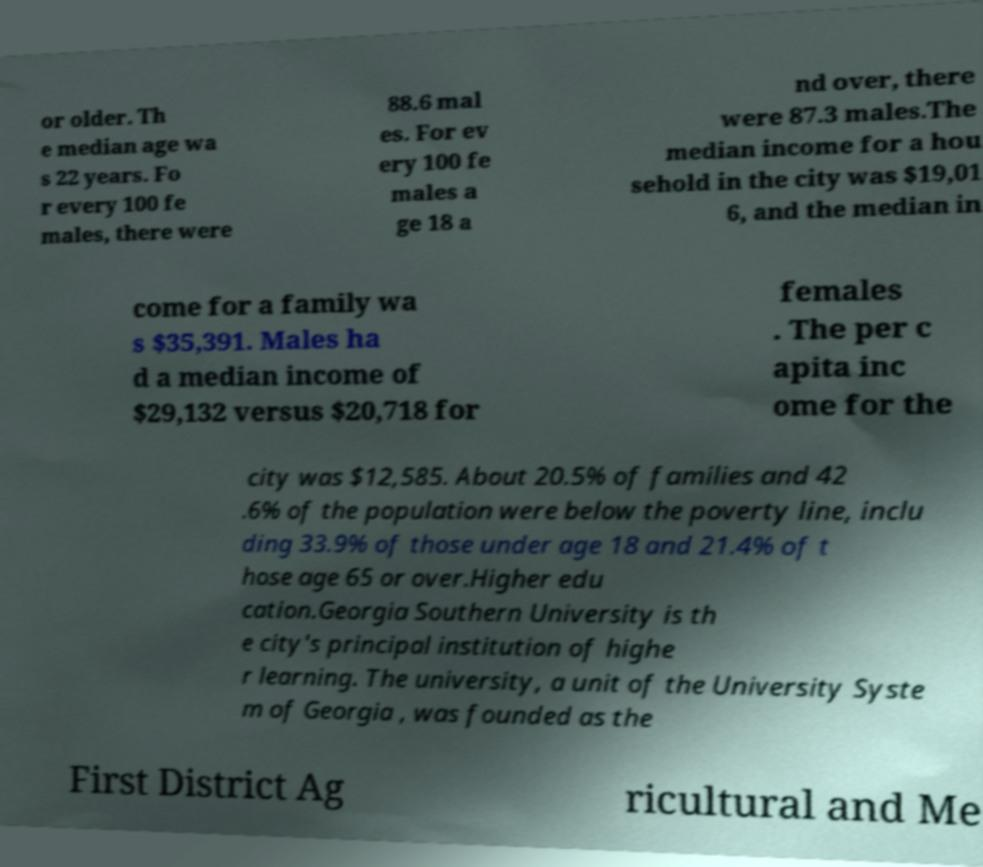Please identify and transcribe the text found in this image. or older. Th e median age wa s 22 years. Fo r every 100 fe males, there were 88.6 mal es. For ev ery 100 fe males a ge 18 a nd over, there were 87.3 males.The median income for a hou sehold in the city was $19,01 6, and the median in come for a family wa s $35,391. Males ha d a median income of $29,132 versus $20,718 for females . The per c apita inc ome for the city was $12,585. About 20.5% of families and 42 .6% of the population were below the poverty line, inclu ding 33.9% of those under age 18 and 21.4% of t hose age 65 or over.Higher edu cation.Georgia Southern University is th e city's principal institution of highe r learning. The university, a unit of the University Syste m of Georgia , was founded as the First District Ag ricultural and Me 